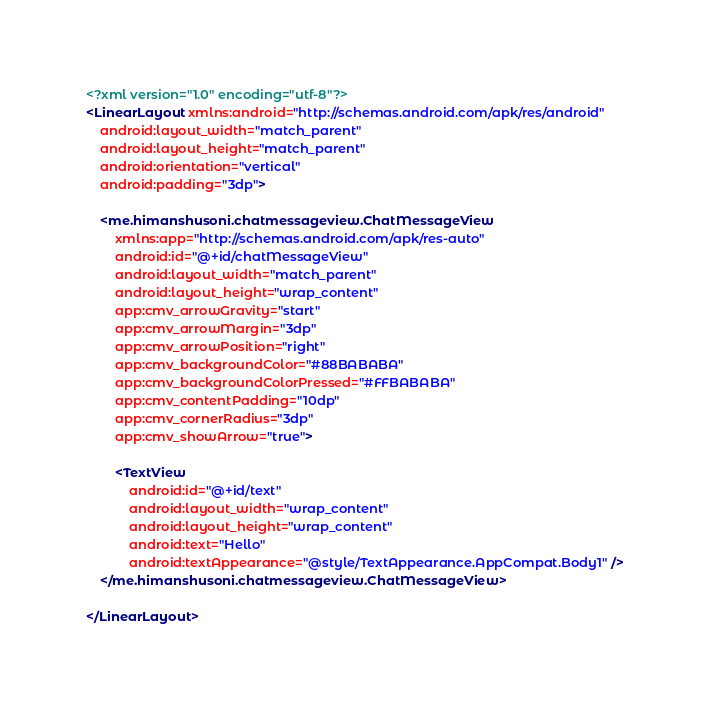Convert code to text. <code><loc_0><loc_0><loc_500><loc_500><_XML_><?xml version="1.0" encoding="utf-8"?>
<LinearLayout xmlns:android="http://schemas.android.com/apk/res/android"
    android:layout_width="match_parent"
    android:layout_height="match_parent"
    android:orientation="vertical"
    android:padding="3dp">

    <me.himanshusoni.chatmessageview.ChatMessageView
        xmlns:app="http://schemas.android.com/apk/res-auto"
        android:id="@+id/chatMessageView"
        android:layout_width="match_parent"
        android:layout_height="wrap_content"
        app:cmv_arrowGravity="start"
        app:cmv_arrowMargin="3dp"
        app:cmv_arrowPosition="right"
        app:cmv_backgroundColor="#88BABABA"
        app:cmv_backgroundColorPressed="#FFBABABA"
        app:cmv_contentPadding="10dp"
        app:cmv_cornerRadius="3dp"
        app:cmv_showArrow="true">

        <TextView
            android:id="@+id/text"
            android:layout_width="wrap_content"
            android:layout_height="wrap_content"
            android:text="Hello"
            android:textAppearance="@style/TextAppearance.AppCompat.Body1" />
    </me.himanshusoni.chatmessageview.ChatMessageView>

</LinearLayout>
</code> 